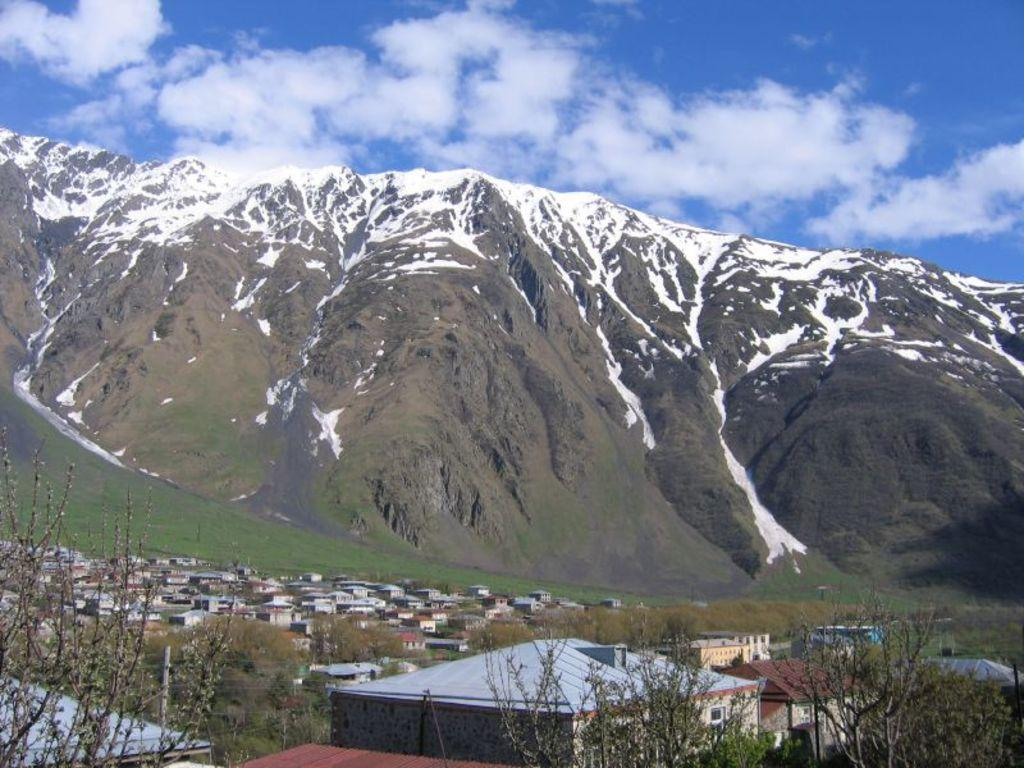What types of structures are located at the bottom of the image? There are buildings and houses at the bottom of the image. What else can be seen at the bottom of the image? There are trees at the bottom of the image. What is visible in the background of the image? There are mountains and grass in the background of the image. What is visible at the top of the image? The sky is visible at the top of the image. Can you tell me how many pockets are visible in the image? There are no pockets present in the image. What type of soup is being served in the image? There is no soup present in the image. 